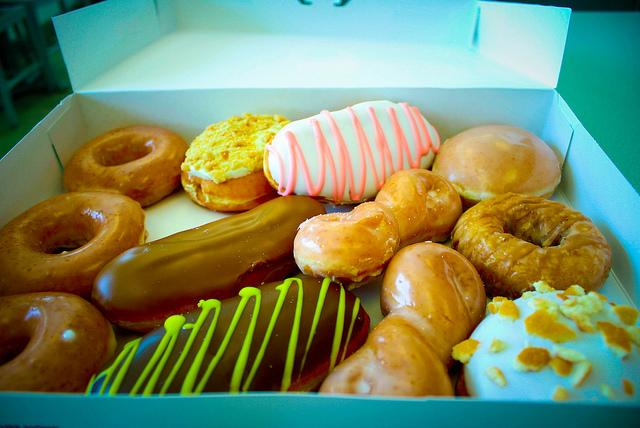What treat is in the box? Please explain your reasoning. donut. The box is filled with a dozen of sweet glazed donuts. 